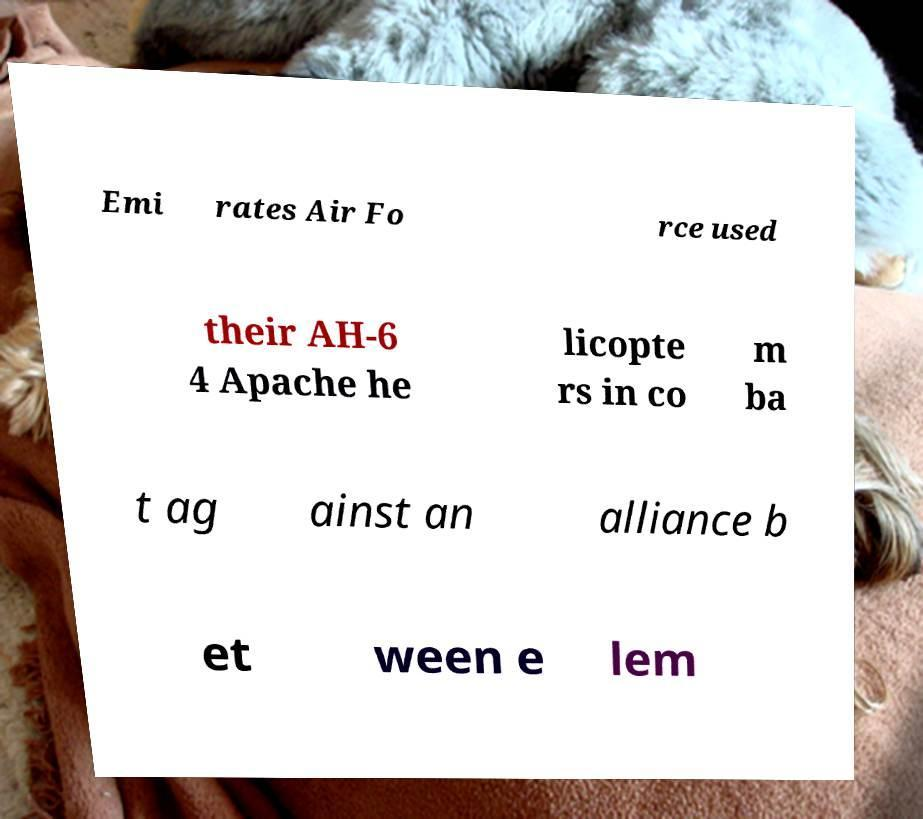Please identify and transcribe the text found in this image. Emi rates Air Fo rce used their AH-6 4 Apache he licopte rs in co m ba t ag ainst an alliance b et ween e lem 